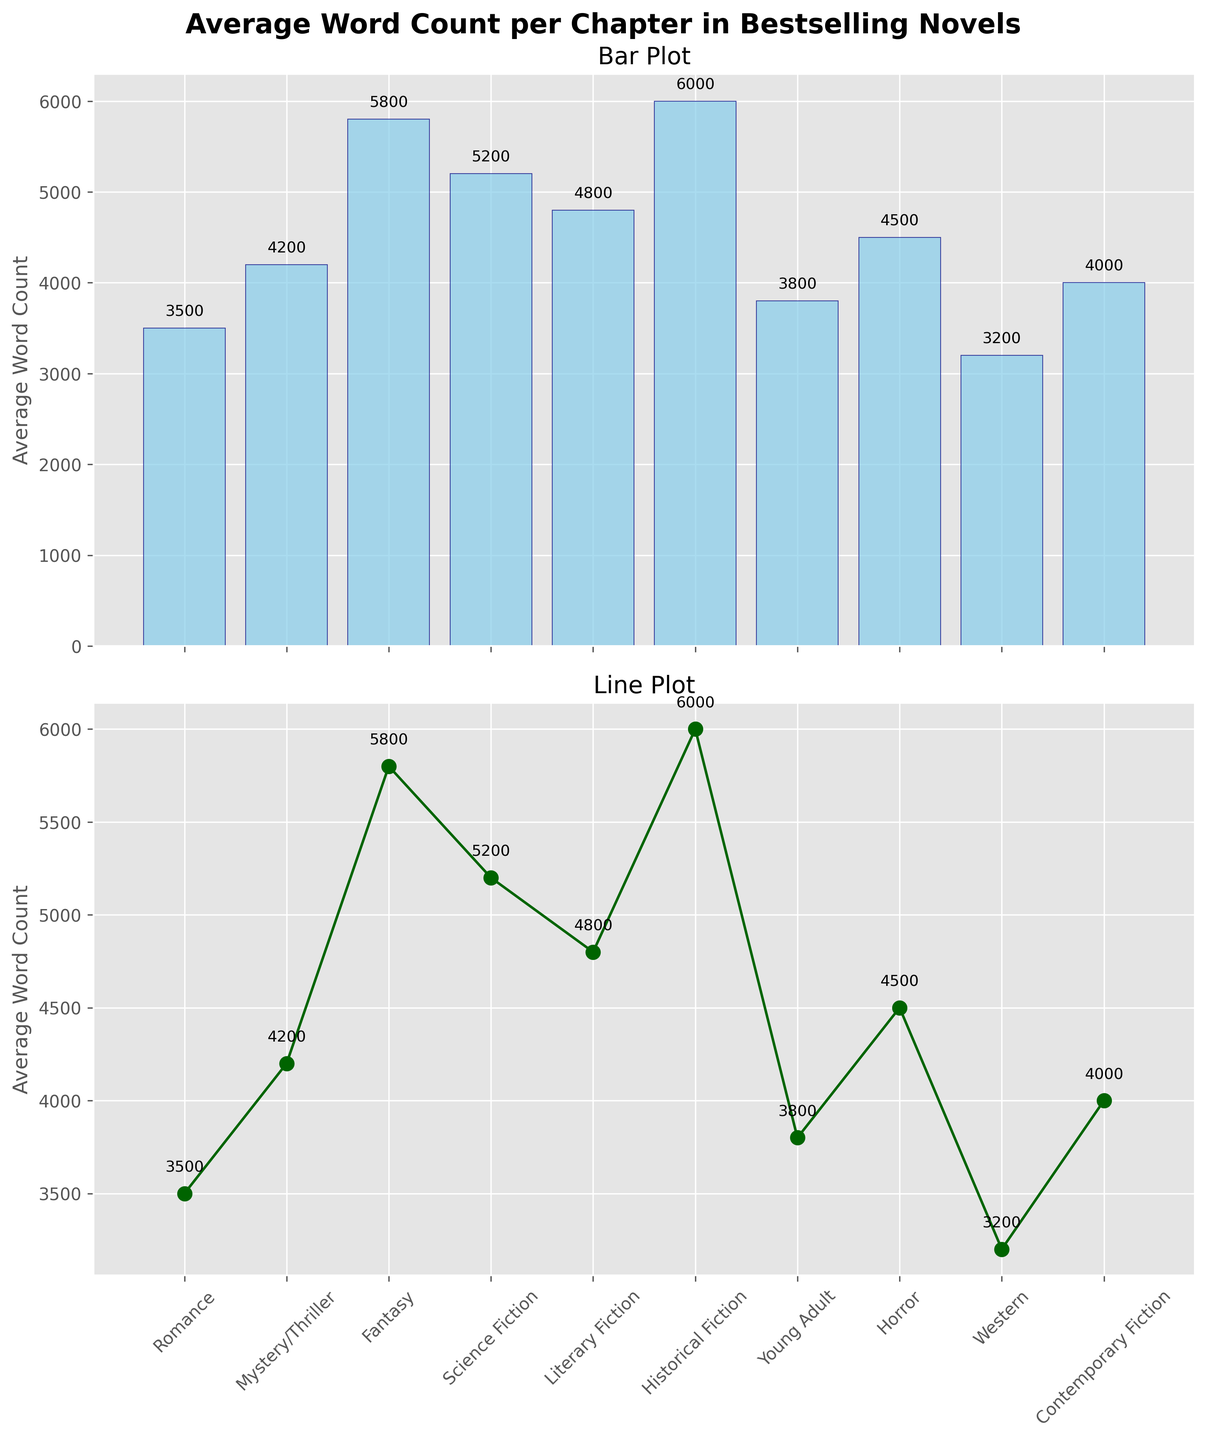What is the title of the plot? The title is located at the top of the figure in bold font. It reads "Average Word Count per Chapter in Bestselling Novels."
Answer: Average Word Count per Chapter in Bestselling Novels Which genre has the lowest average word count? By examining both the bar and line plots, the genre with the lowest bar and line marker is "Western," indicating it has the lowest average word count.
Answer: Western How many genres are shown in the plot? Counting the bars or data points on the x-axis of either subplot reveals the number of genres. There are 10 genres displayed.
Answer: 10 Which genre has the highest average word count? Both the bar plot and the line plot show that "Historical Fiction" has the highest peak, making it the genre with the highest average word count.
Answer: Historical Fiction What is the average word count for the Science Fiction genre? Looking at the position of the Science Fiction marker on either the bar or line plot, the value is labeled as 5,200.
Answer: 5,200 Which genres have an average word count higher than 5,000? By examining the data points above the 5,000 mark on either plot, the genres are Fantasy (5,800), Science Fiction (5,200), Literary Fiction (4,800) is not greater than 5,000, and Historical Fiction (6,000).
Answer: Fantasy and Historical Fiction What is the difference in average word count between the genre with the highest and the genre with the lowest? The highest average word count is 6,000 (Historical Fiction), and the lowest is 3,200 (Western). The difference is 6,000 - 3,200.
Answer: 2,800 Which genre's average word count is closest to the overall mean of all genres? Calculating the mean of the average word counts (∑ word counts / number of genres) results in 45200/10 = 4520. Literary Fiction's average word count of 4,800 is closest to this value.
Answer: Literary Fiction Is there any genre where the average word count is exactly 4,500? By visually inspecting the line or bar plot, we can spot the average word count of exactly 4,500. The genre is Horror.
Answer: Horror What is the total sum of the average word counts for all genres? The sum of all the average word counts is (3,500+4,200+5,800+5,200+4,800+6,000+3,800+4,500+3,200+4,000). Adding these values gives a total of 45,000.
Answer: 45,000 